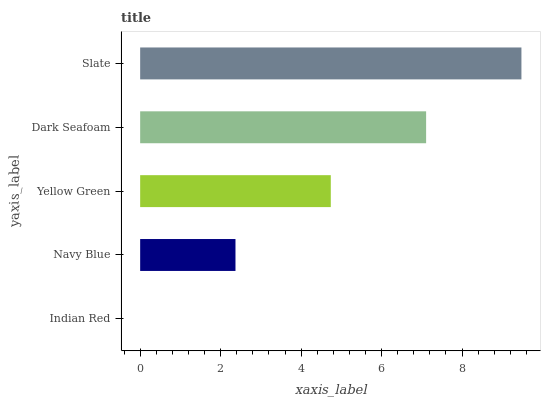Is Indian Red the minimum?
Answer yes or no. Yes. Is Slate the maximum?
Answer yes or no. Yes. Is Navy Blue the minimum?
Answer yes or no. No. Is Navy Blue the maximum?
Answer yes or no. No. Is Navy Blue greater than Indian Red?
Answer yes or no. Yes. Is Indian Red less than Navy Blue?
Answer yes or no. Yes. Is Indian Red greater than Navy Blue?
Answer yes or no. No. Is Navy Blue less than Indian Red?
Answer yes or no. No. Is Yellow Green the high median?
Answer yes or no. Yes. Is Yellow Green the low median?
Answer yes or no. Yes. Is Slate the high median?
Answer yes or no. No. Is Indian Red the low median?
Answer yes or no. No. 